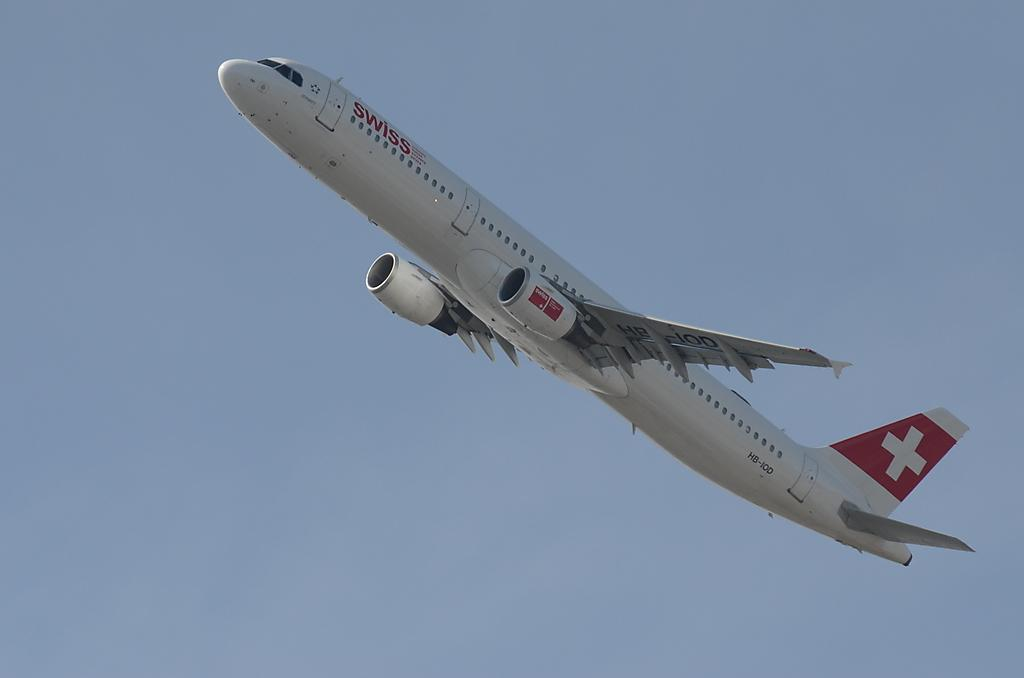What is the main subject of the image? The main subject of the image is an airplane. What is the airplane doing in the image? The airplane is flying in the sky. How does the airplane measure the distance it has traveled in the image? The image does not show any specific method of measuring distance, and the airplane's distance traveled cannot be determined from the image. 